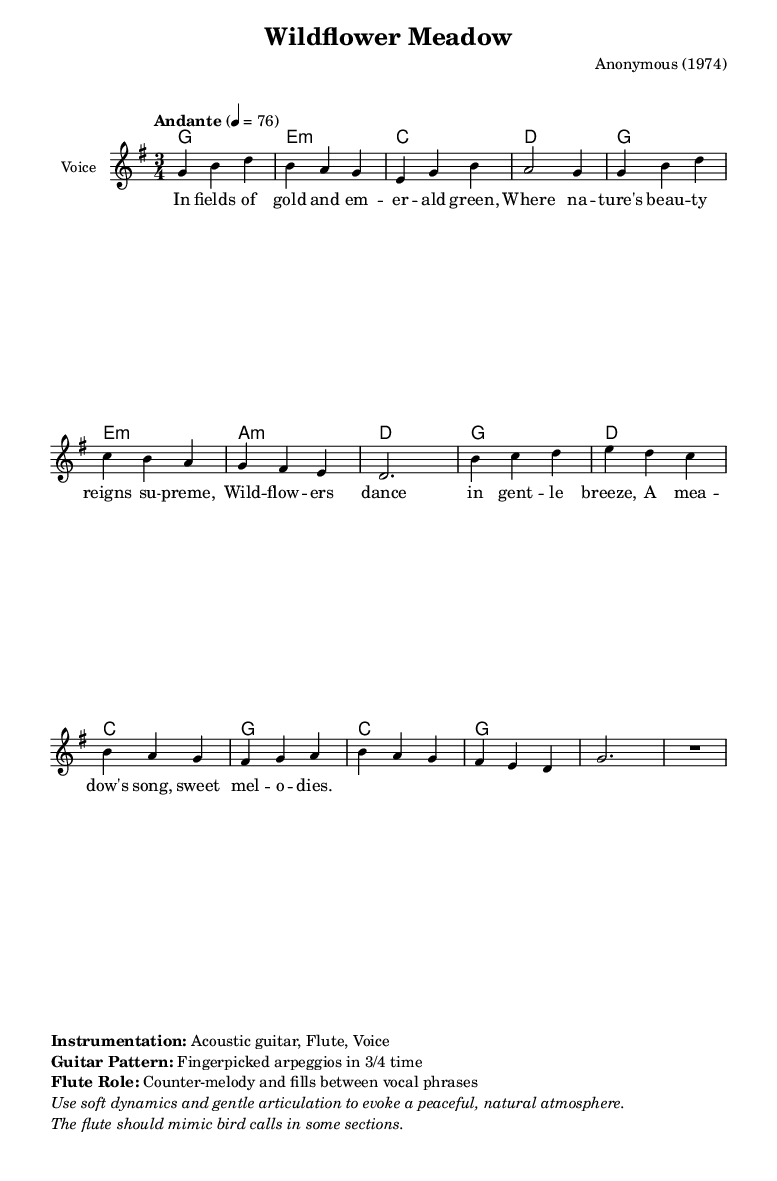What is the key signature of this music? The key signature indicates that the piece is in G major, which has one sharp (F#). This is identified by looking at the key signature mark at the beginning of the staff.
Answer: G major What is the time signature of this music? The time signature is found just after the key signature at the beginning of the score. It shows that there are three beats in each measure, indicating a 3/4 time signature.
Answer: 3/4 What is the tempo marking for this piece? The tempo marking appears at the start of the score, stating "Andante" with a metronome marking of 4 = 76, which indicates a moderate walking pace.
Answer: Andante, 76 What is the primary instrumentation used in this piece? The instrumentation is listed in the markup section of the code, indicating what instruments are intended to play. In this case, it specifies "Acoustic guitar, Flute, Voice."
Answer: Acoustic guitar, Flute, Voice How many measures are in the melody section? To determine this, we can count the number of distinct measures in the melody code section, which are separated by vertical lines. There are a total of fourteen measures.
Answer: 14 What is the effect of using fingerpicked arpeggios on the guitar in this piece? The markup mentions that the "Guitar Pattern" consists of fingerpicked arpeggios, which creates a gentle, flowing texture typical of folk ballads. This style enhances the tranquil atmosphere and complements the lyrical content about nature.
Answer: Gentle, flowing texture 